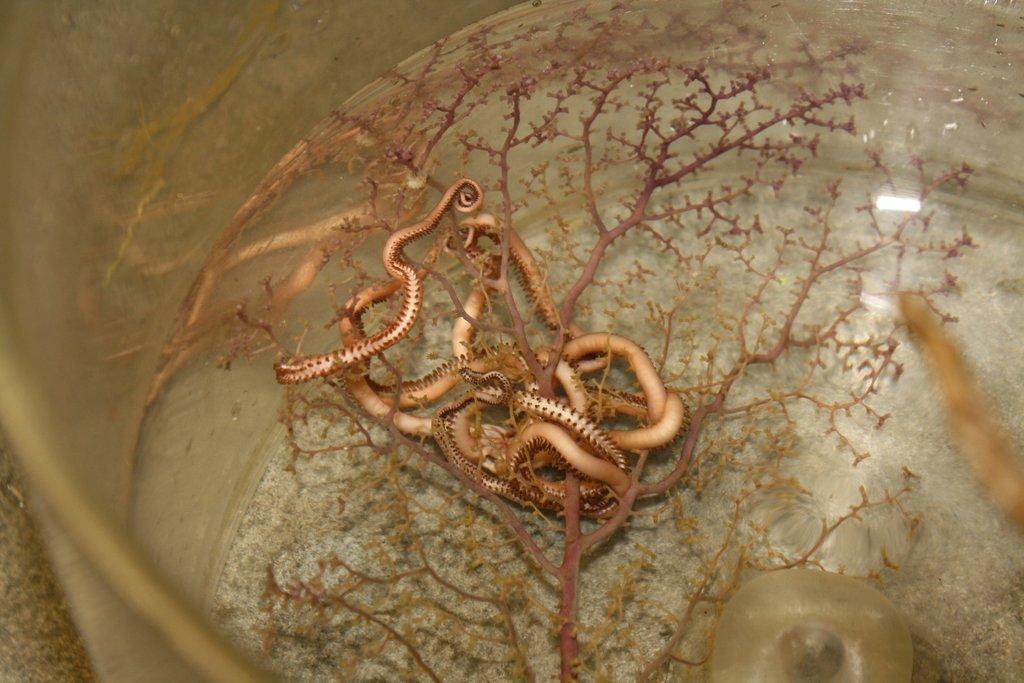How would you summarize this image in a sentence or two? In this image, we can see a container. In the container, we can see water, warms and stems. This container is placed on the surface. 